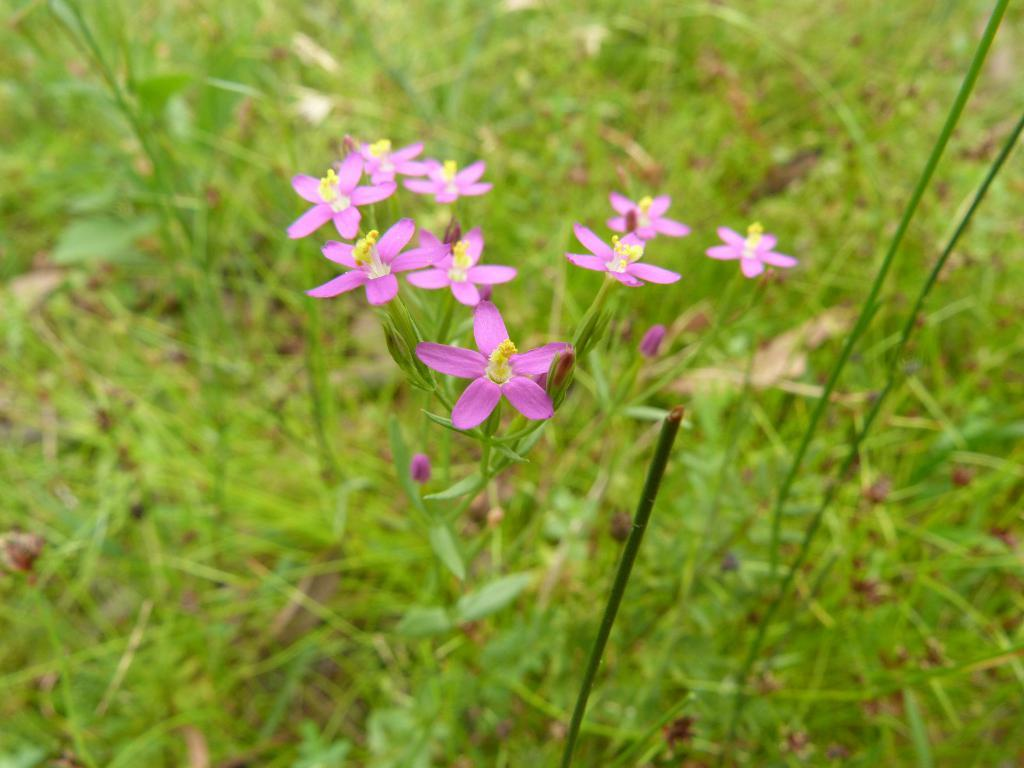Where was the picture taken? The picture was taken outside. What is the main subject in the center of the image? There is a group of flowers in the center of the image. What type of vegetation can be seen in the image? There is green grass visible in the image. How many ducks are flying in the air in the image? There are no ducks or any indication of flying in the image. 